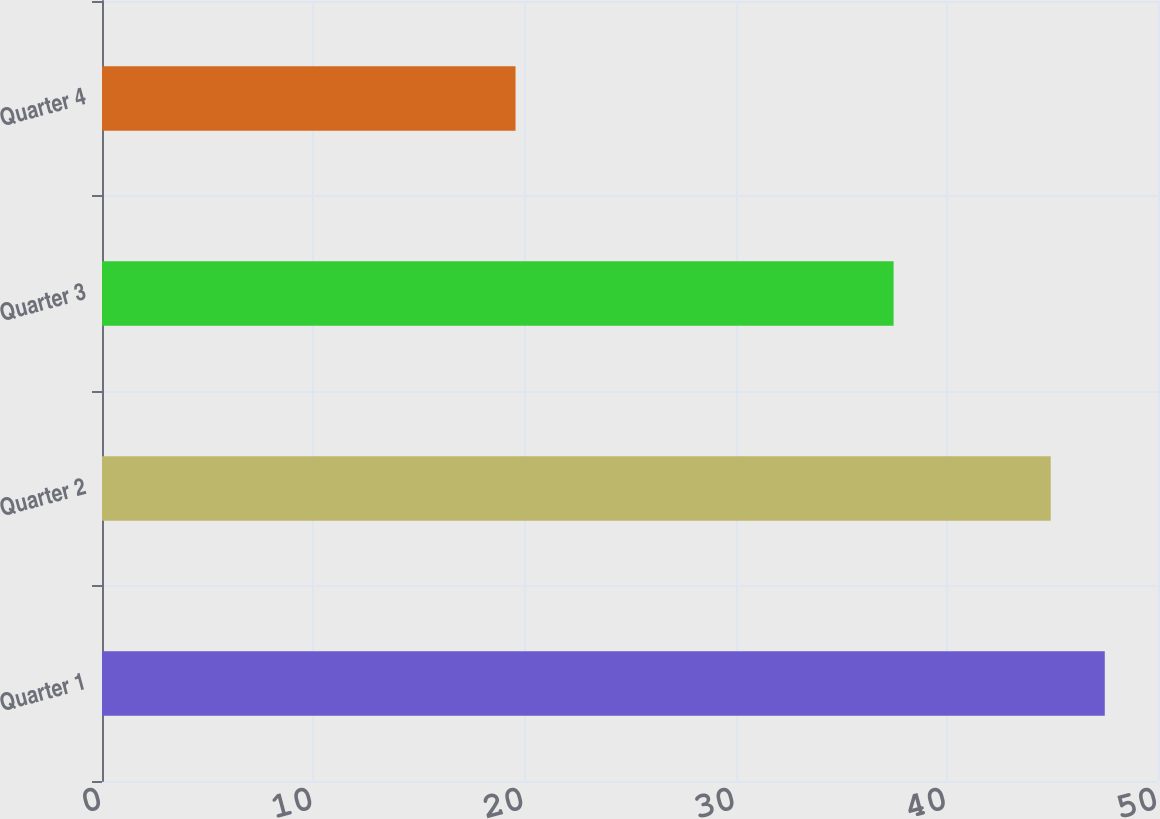Convert chart. <chart><loc_0><loc_0><loc_500><loc_500><bar_chart><fcel>Quarter 1<fcel>Quarter 2<fcel>Quarter 3<fcel>Quarter 4<nl><fcel>47.48<fcel>44.92<fcel>37.48<fcel>19.58<nl></chart> 